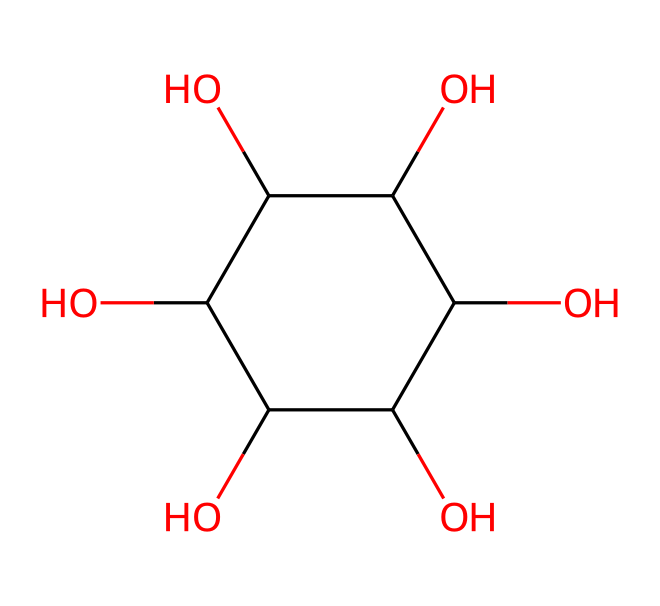What is the molecular formula of this sugar? The molecular formula can be deduced by counting the carbon, hydrogen, and oxygen atoms in the structure. There are six carbon atoms, twelve hydrogen atoms, and six oxygen atoms, which gives the formula C6H12O6.
Answer: C6H12O6 How many hydroxyl (–OH) groups are present in this structure? By examining the structure, we can identify the hydroxyl groups: there are five –OH groups attached to various carbon atoms in the sugar molecule.
Answer: 5 What type of solid does this sugar form? The crystalline structure indicates that this sugar forms a crystalline solid, as sugars typically possess a regular, repeating arrangement of atoms.
Answer: crystalline solid What is the predominant type of bonding in this sugar molecule? This sugar molecule predominantly exhibits covalent bonding, as the atoms are bonded through shared pairs of electrons.
Answer: covalent Does this sugar belong to the group of monosaccharides? This molecule is a hexose sugar, which is a type of monosaccharide, meaning it consists of a single sugar unit.
Answer: yes How many rings are present in the structure of this sugar? The structure shows that it has one ring, which is characteristic of many sugars that cyclize to form a ring structure when dissolved in water.
Answer: 1 